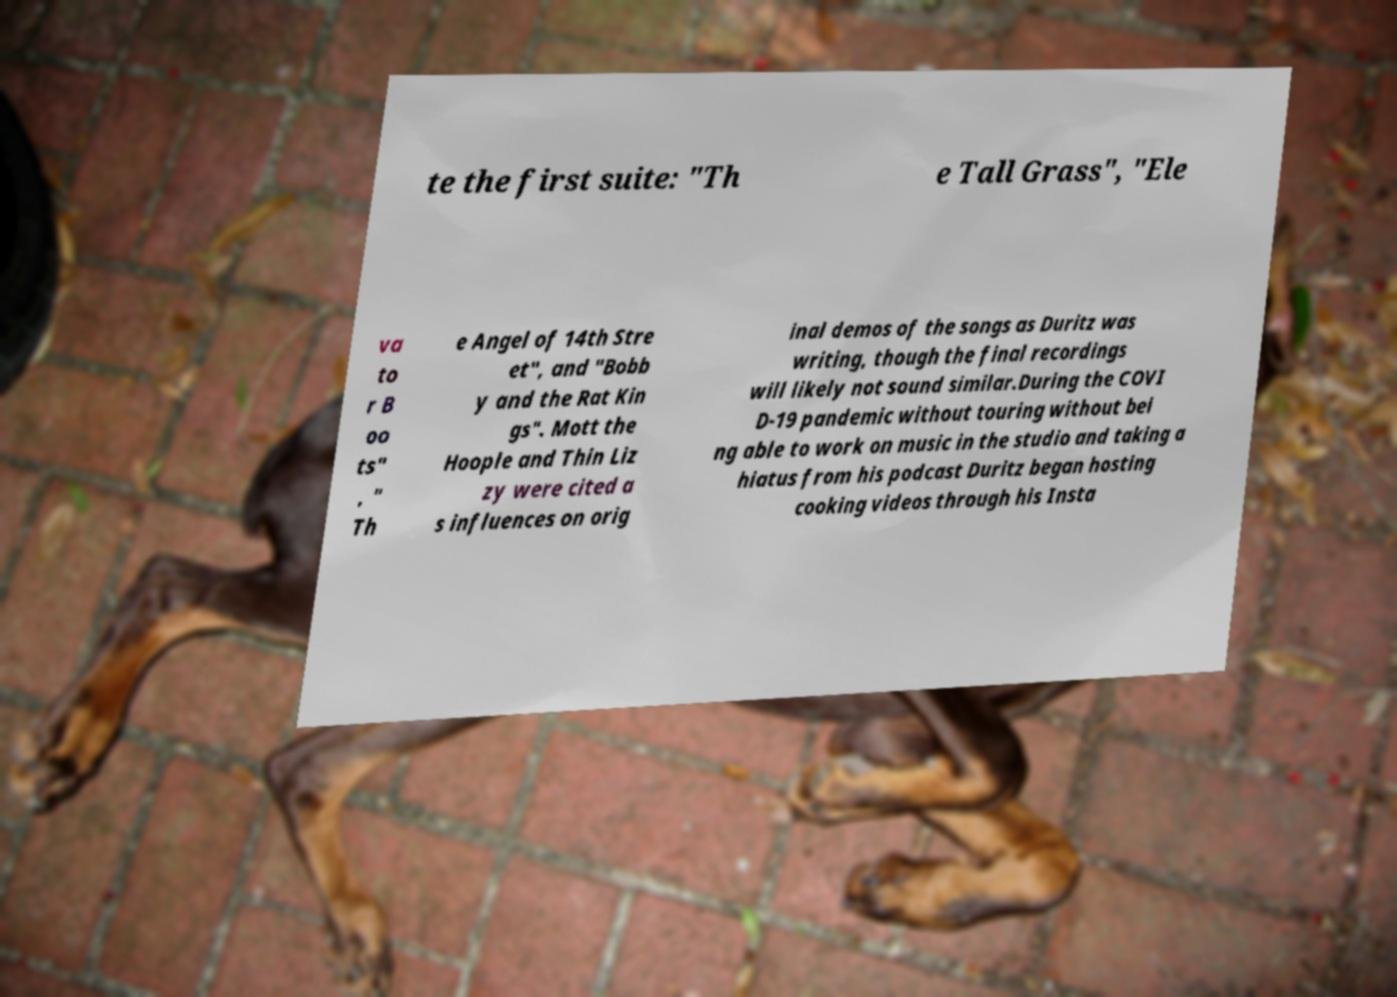For documentation purposes, I need the text within this image transcribed. Could you provide that? te the first suite: "Th e Tall Grass", "Ele va to r B oo ts" , " Th e Angel of 14th Stre et", and "Bobb y and the Rat Kin gs". Mott the Hoople and Thin Liz zy were cited a s influences on orig inal demos of the songs as Duritz was writing, though the final recordings will likely not sound similar.During the COVI D-19 pandemic without touring without bei ng able to work on music in the studio and taking a hiatus from his podcast Duritz began hosting cooking videos through his Insta 